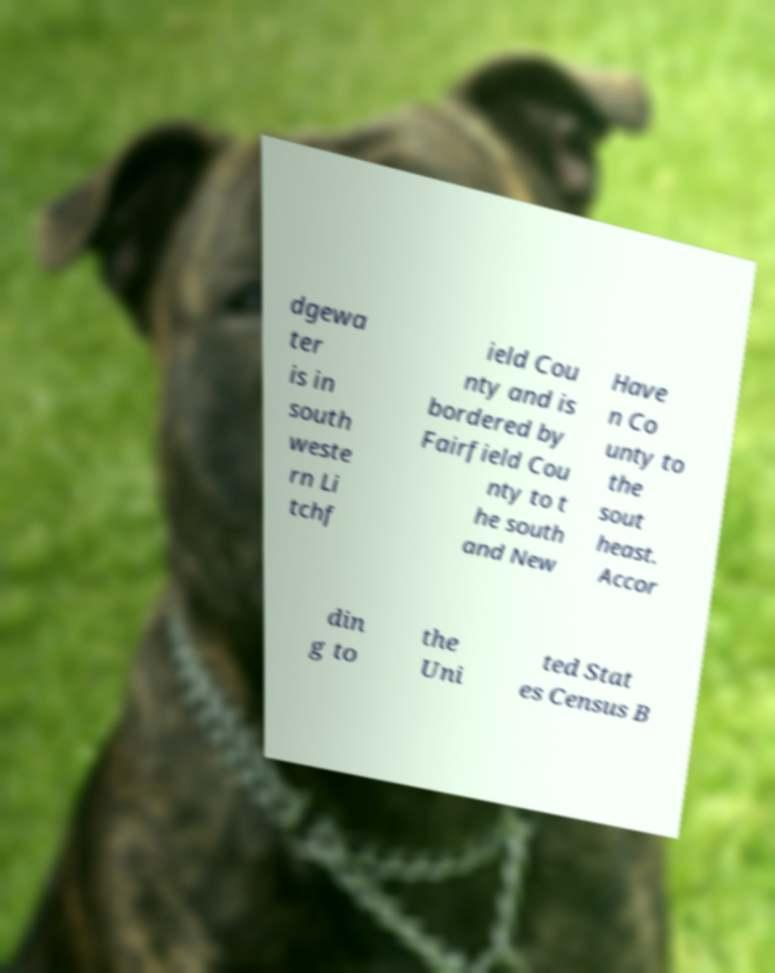Please identify and transcribe the text found in this image. dgewa ter is in south weste rn Li tchf ield Cou nty and is bordered by Fairfield Cou nty to t he south and New Have n Co unty to the sout heast. Accor din g to the Uni ted Stat es Census B 